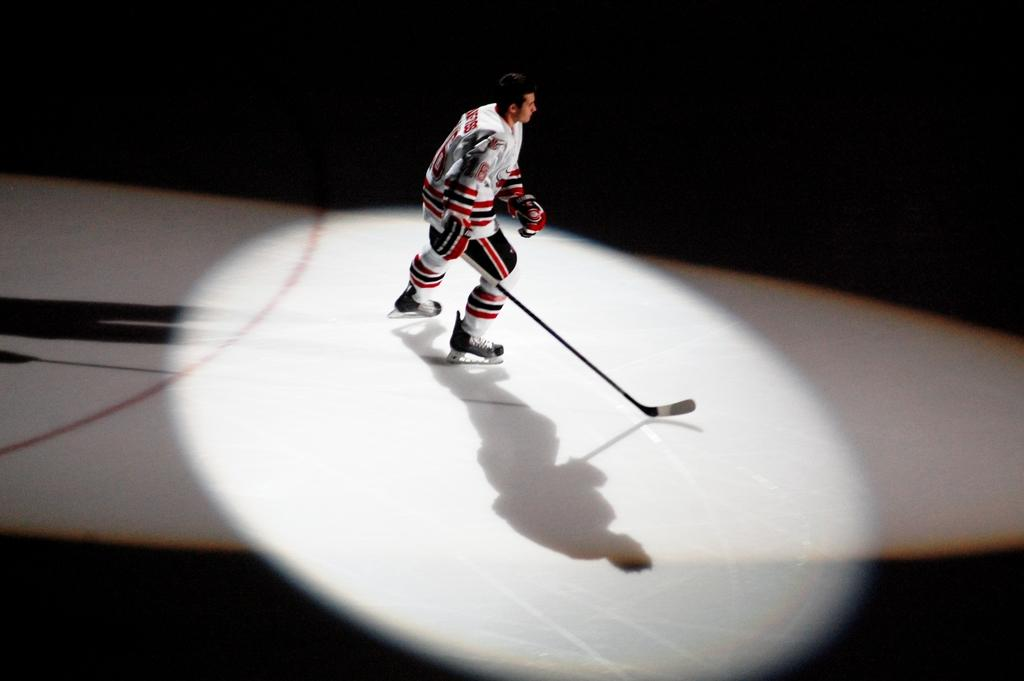What is the main subject of the image? The main subject of the image is a player. What is the player holding in his hand? The player is holding a stick in his hand. Can you describe any additional elements in the image? There is a spotlight on the player. How many cakes are being shared among the players in the image? There are no cakes present in the image; it only features a player holding a stick and a spotlight. 